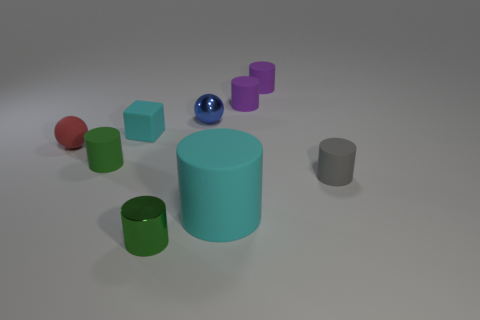Subtract all purple rubber cylinders. How many cylinders are left? 4 Subtract all purple cylinders. How many cylinders are left? 4 Subtract all yellow spheres. How many green cylinders are left? 2 Subtract all large rubber things. Subtract all blocks. How many objects are left? 7 Add 7 small purple things. How many small purple things are left? 9 Add 6 big yellow shiny cubes. How many big yellow shiny cubes exist? 6 Subtract 0 green spheres. How many objects are left? 9 Subtract all cylinders. How many objects are left? 3 Subtract 5 cylinders. How many cylinders are left? 1 Subtract all green balls. Subtract all green blocks. How many balls are left? 2 